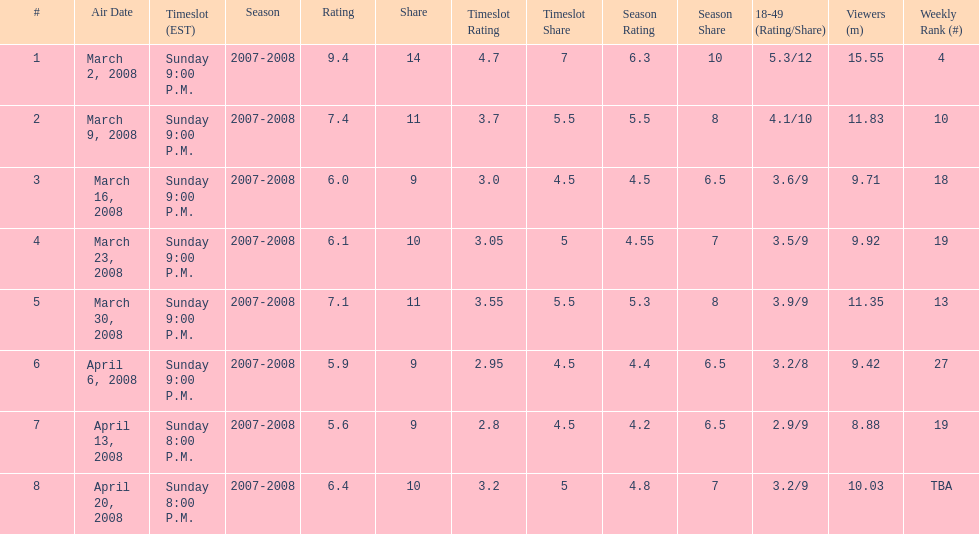Did the season finish at an earlier or later timeslot? Earlier. 